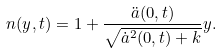Convert formula to latex. <formula><loc_0><loc_0><loc_500><loc_500>n ( y , t ) = 1 + \frac { \ddot { a } ( 0 , t ) } { \sqrt { \dot { a } ^ { 2 } ( 0 , t ) + k } } y .</formula> 